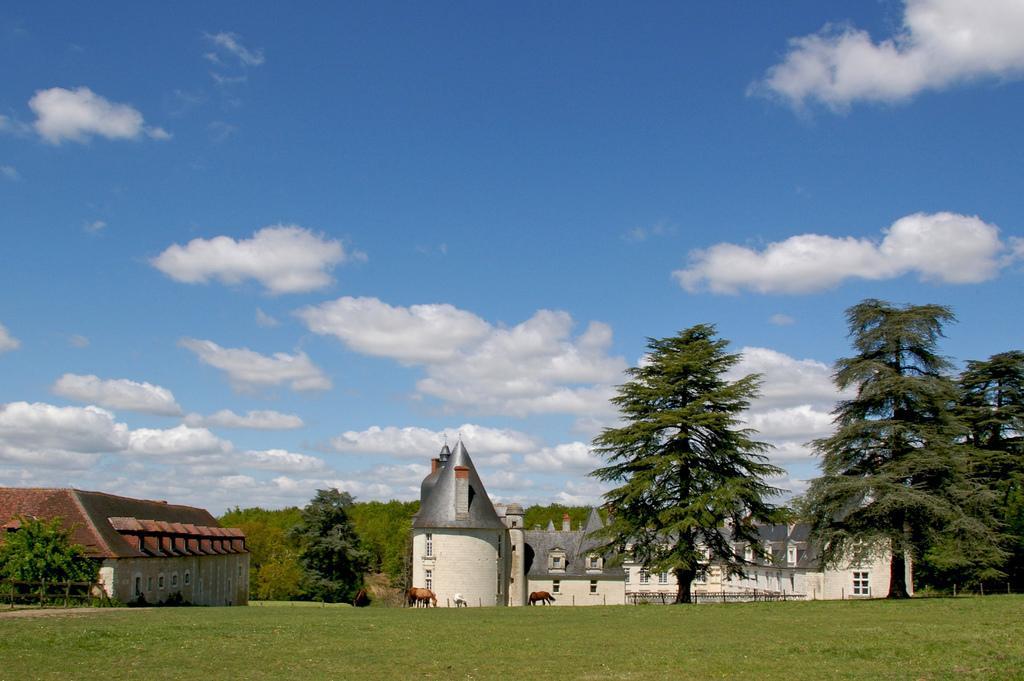In one or two sentences, can you explain what this image depicts? In this image there are animals on the grassland having a fence. Background there are trees and buildings. Top of the image there is sky, having clouds. 